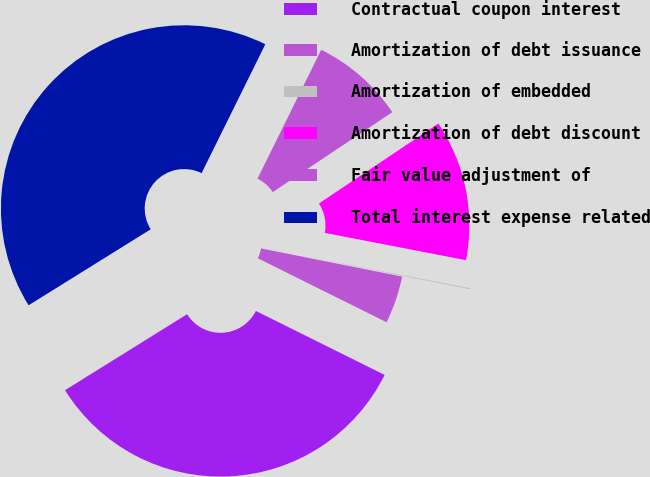Convert chart. <chart><loc_0><loc_0><loc_500><loc_500><pie_chart><fcel>Contractual coupon interest<fcel>Amortization of debt issuance<fcel>Amortization of embedded<fcel>Amortization of debt discount<fcel>Fair value adjustment of<fcel>Total interest expense related<nl><fcel>33.8%<fcel>4.2%<fcel>0.1%<fcel>12.42%<fcel>8.31%<fcel>41.17%<nl></chart> 